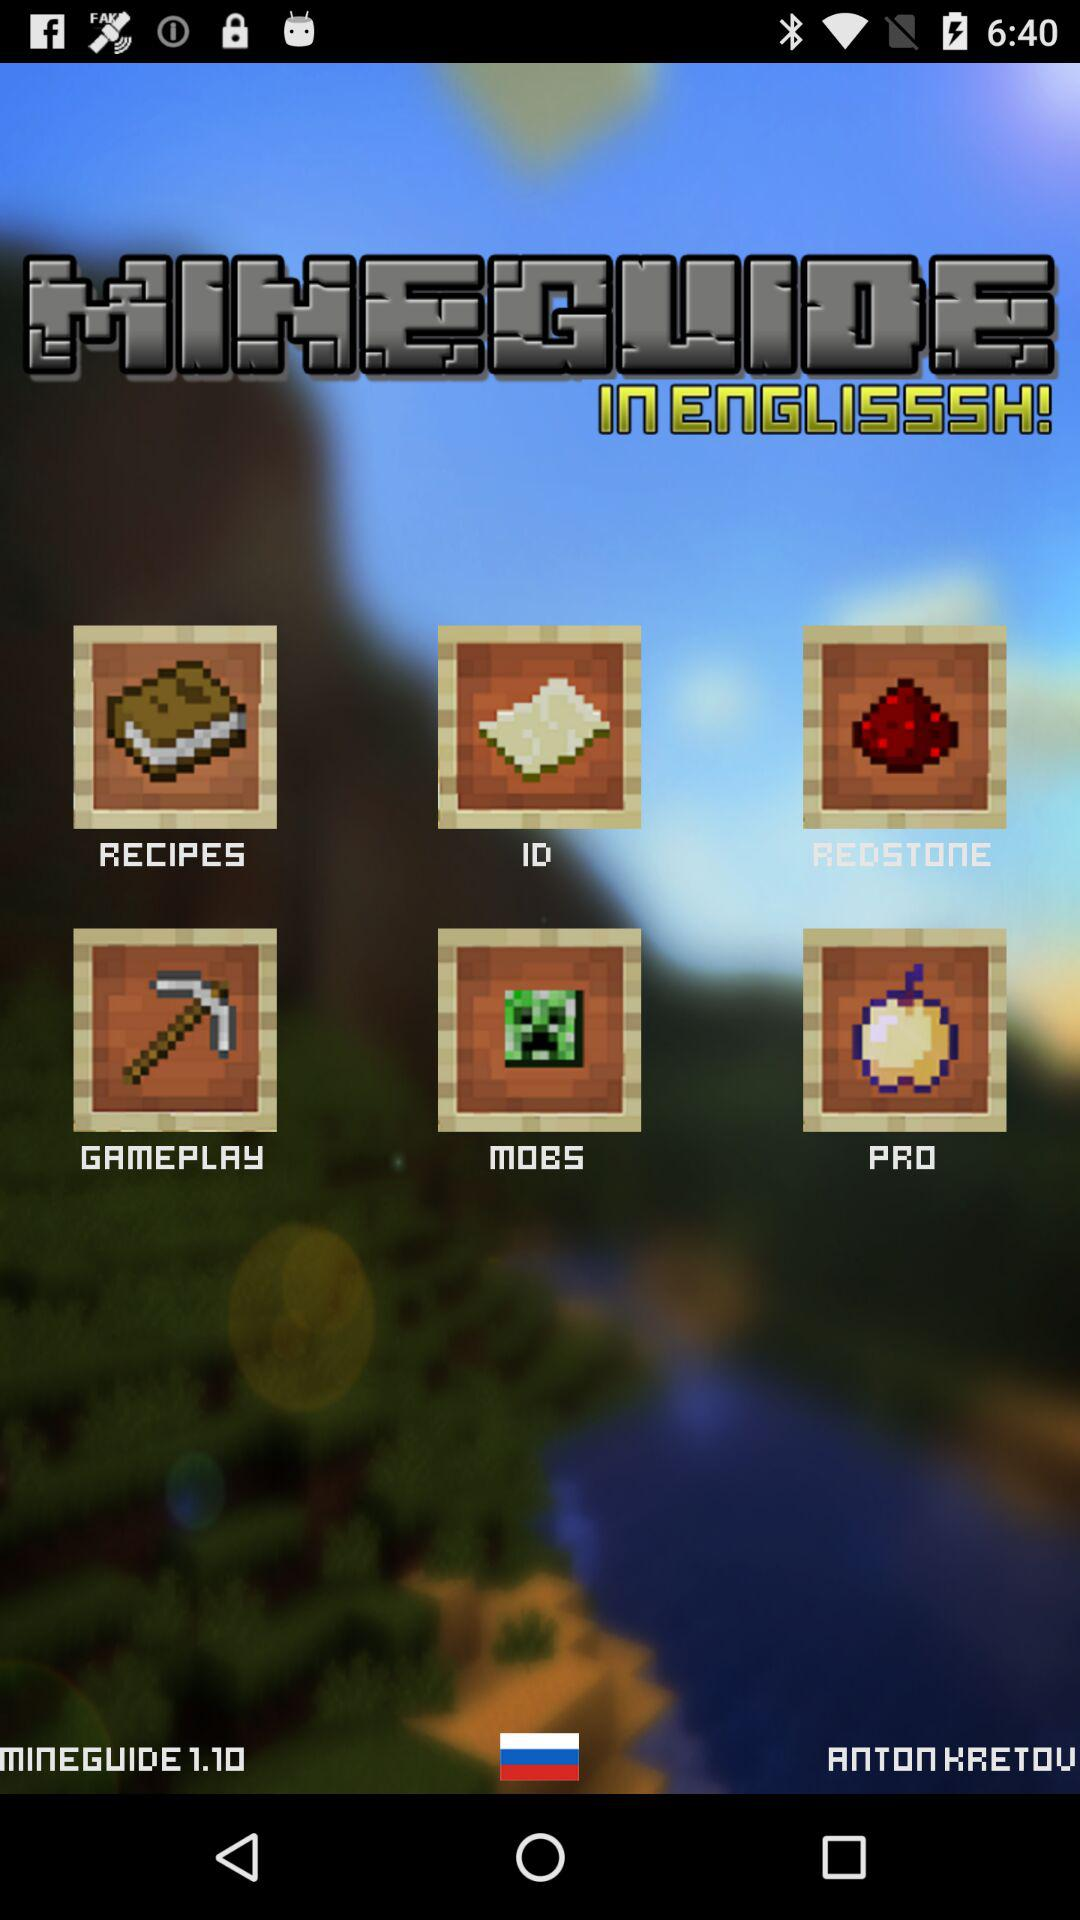What is the user name? The user name is Anton Kretov. 